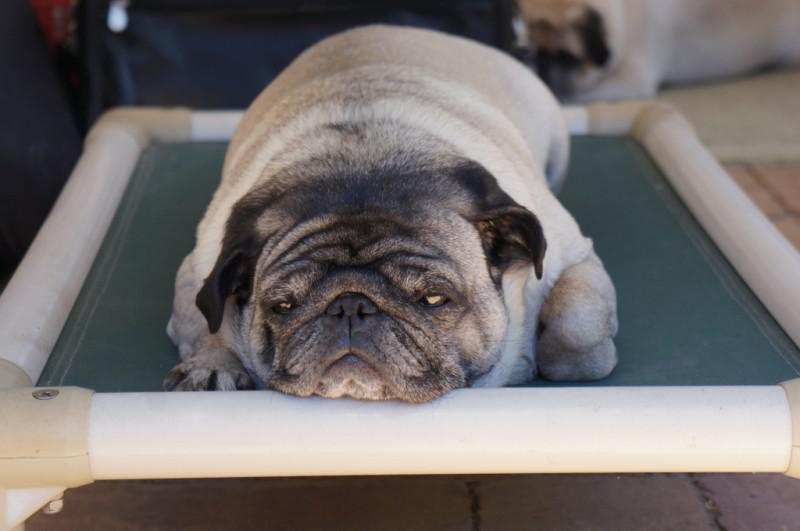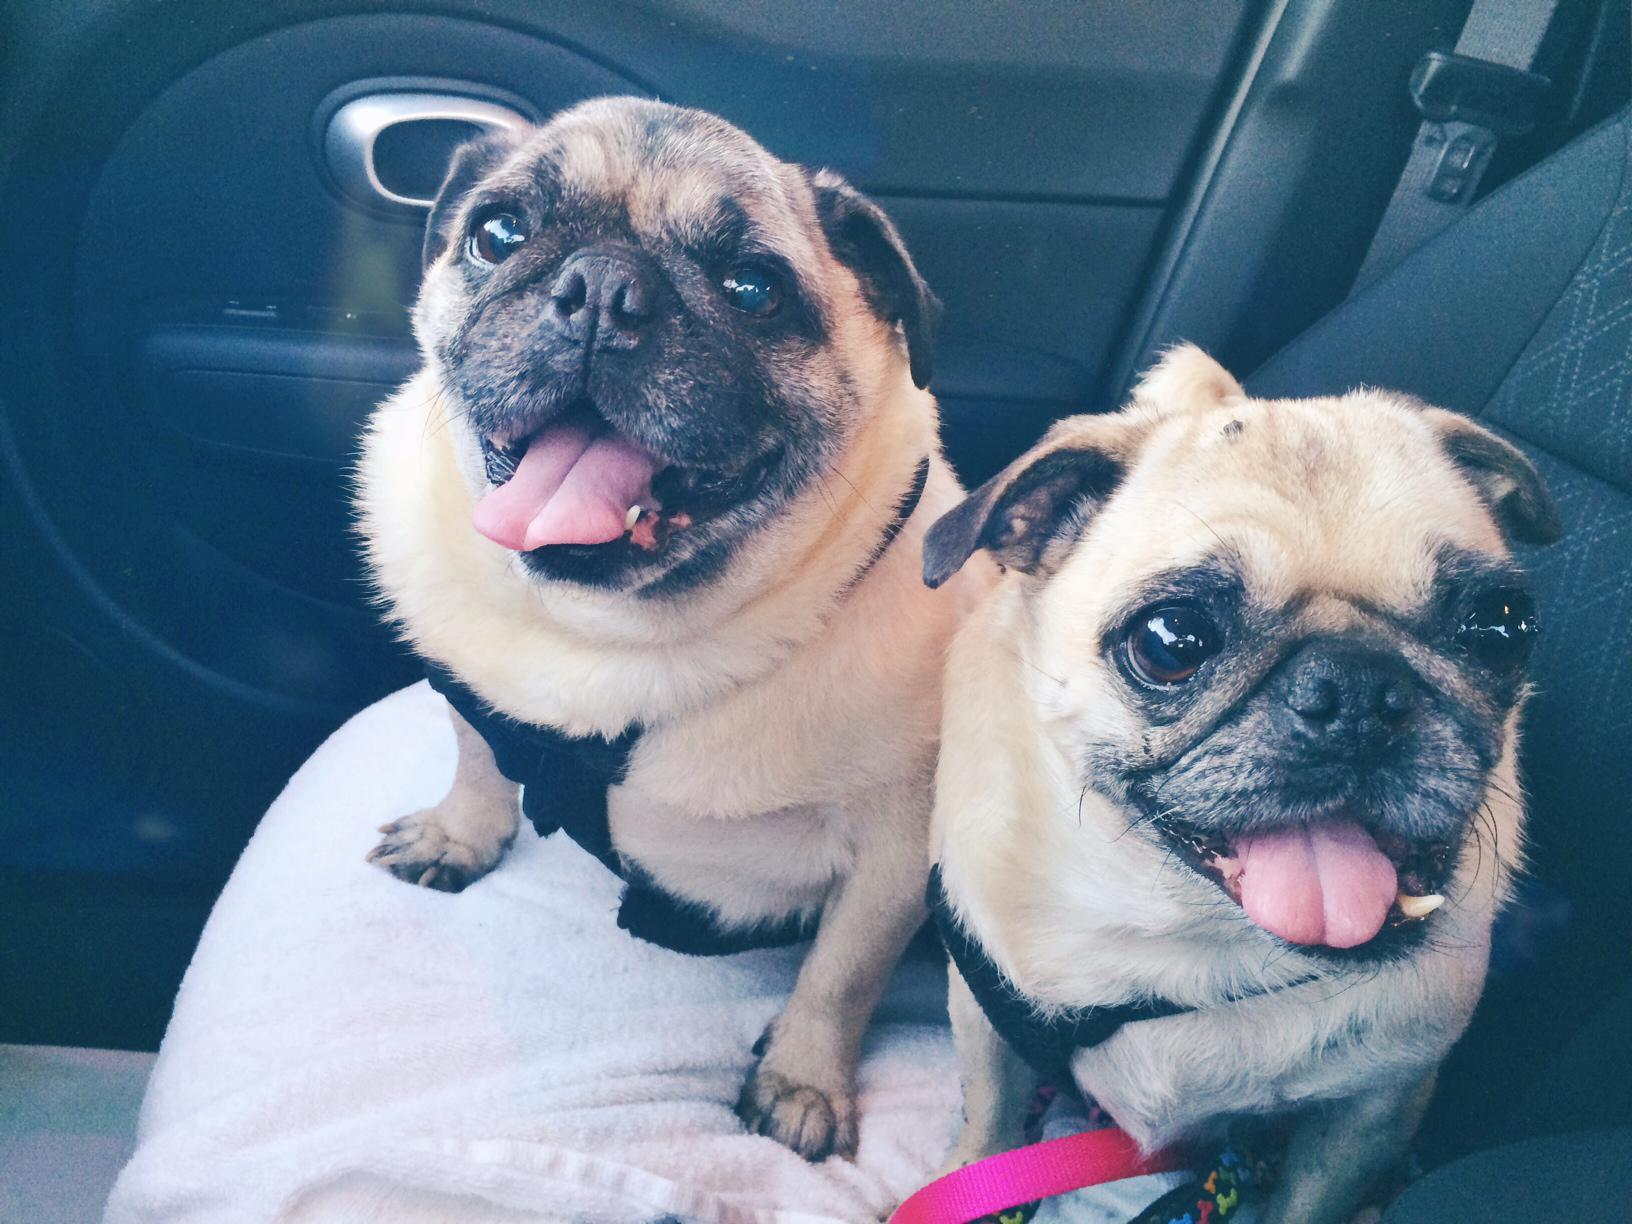The first image is the image on the left, the second image is the image on the right. For the images displayed, is the sentence "One of the images has more than one dog." factually correct? Answer yes or no. Yes. The first image is the image on the left, the second image is the image on the right. For the images displayed, is the sentence "Each image contains one buff-beige pug with a dark muzzle, and one pug is on an orange cushion while the other is lying flat on its belly." factually correct? Answer yes or no. No. 